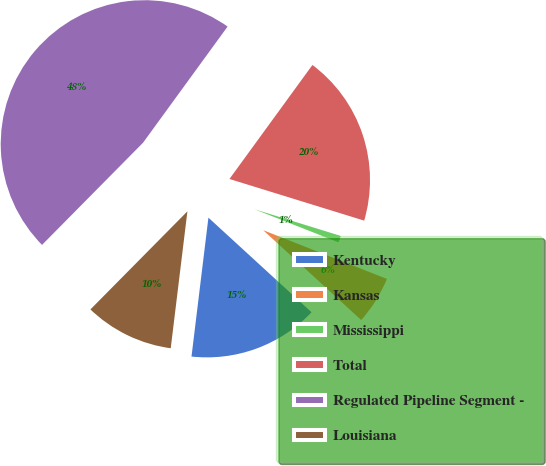Convert chart. <chart><loc_0><loc_0><loc_500><loc_500><pie_chart><fcel>Kentucky<fcel>Kansas<fcel>Mississippi<fcel>Total<fcel>Regulated Pipeline Segment -<fcel>Louisiana<nl><fcel>15.12%<fcel>5.84%<fcel>1.2%<fcel>19.76%<fcel>47.61%<fcel>10.48%<nl></chart> 